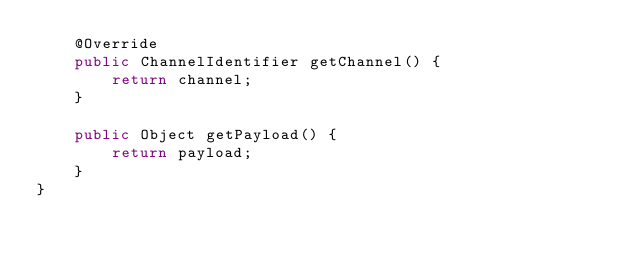<code> <loc_0><loc_0><loc_500><loc_500><_Java_>    @Override
    public ChannelIdentifier getChannel() {
        return channel;
    }

    public Object getPayload() {
        return payload;
    }
}
</code> 